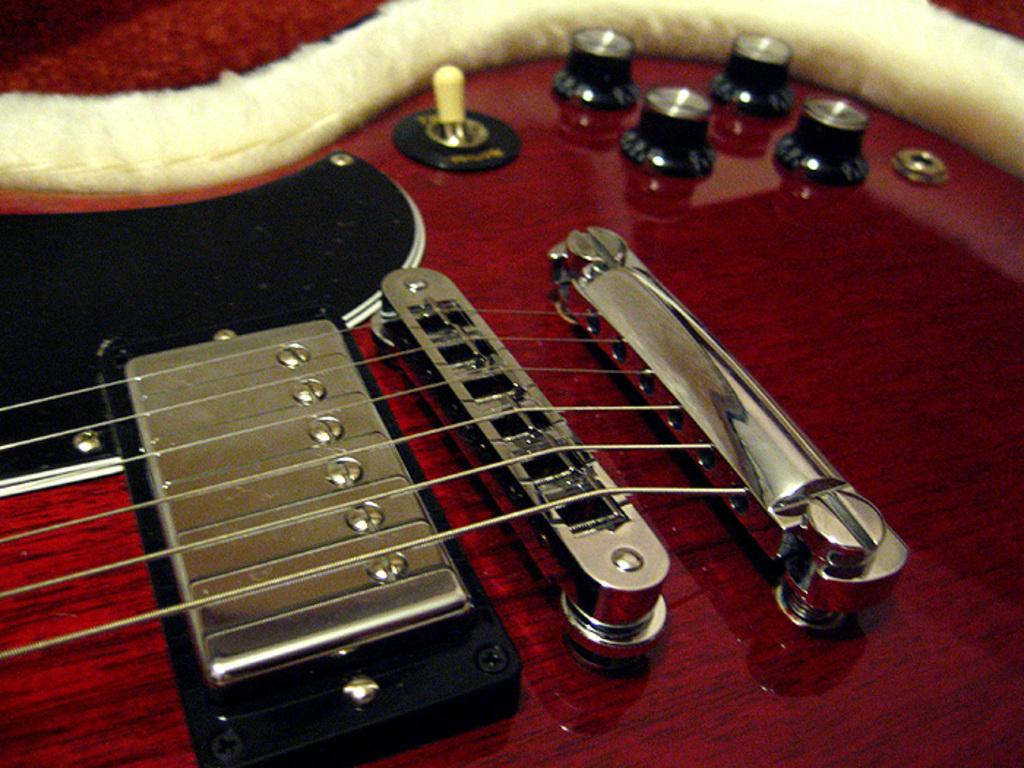What is the main object in the center of the image? There is a guitar in the center of the image. What feature of the guitar is mentioned in the facts? The guitar has strings. What type of root can be seen growing from the guitar in the image? There is no root growing from the guitar in the image. What part of the guitar is made of flesh? The guitar is not made of flesh; it is a musical instrument made of materials like wood and metal. 